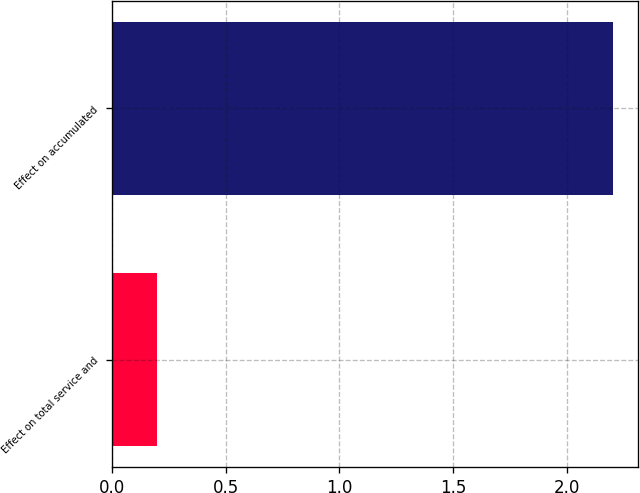Convert chart to OTSL. <chart><loc_0><loc_0><loc_500><loc_500><bar_chart><fcel>Effect on total service and<fcel>Effect on accumulated<nl><fcel>0.2<fcel>2.2<nl></chart> 